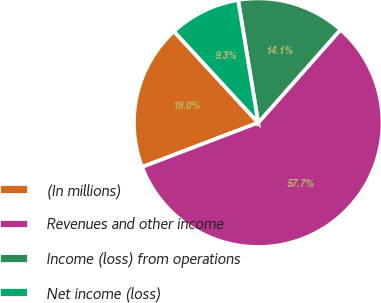<chart> <loc_0><loc_0><loc_500><loc_500><pie_chart><fcel>(In millions)<fcel>Revenues and other income<fcel>Income (loss) from operations<fcel>Net income (loss)<nl><fcel>18.95%<fcel>57.67%<fcel>14.11%<fcel>9.27%<nl></chart> 